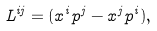<formula> <loc_0><loc_0><loc_500><loc_500>L ^ { i j } = ( x ^ { i } p ^ { j } - x ^ { j } p ^ { i } ) ,</formula> 